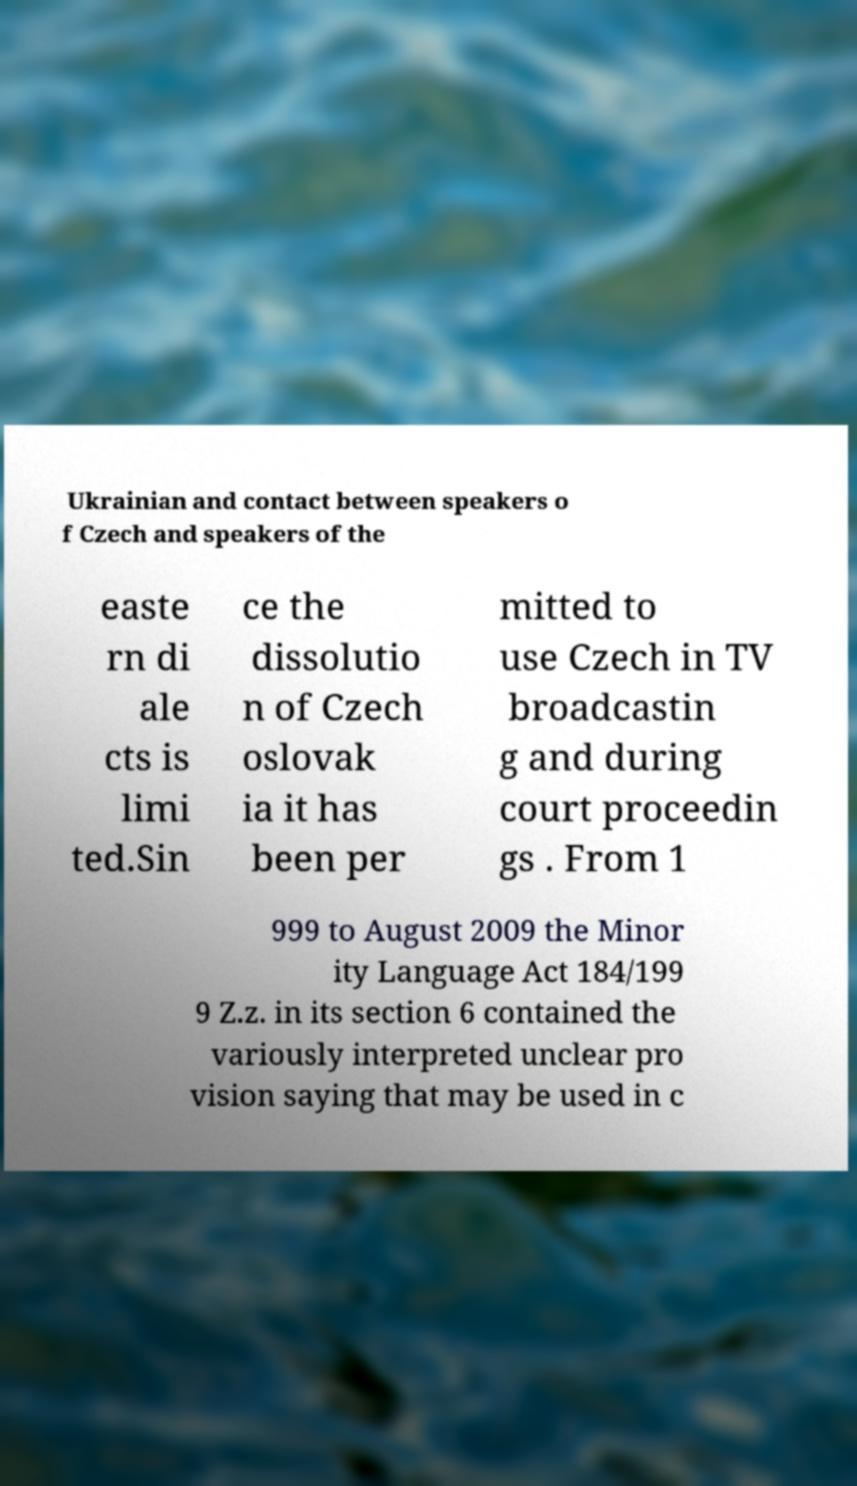Can you read and provide the text displayed in the image?This photo seems to have some interesting text. Can you extract and type it out for me? Ukrainian and contact between speakers o f Czech and speakers of the easte rn di ale cts is limi ted.Sin ce the dissolutio n of Czech oslovak ia it has been per mitted to use Czech in TV broadcastin g and during court proceedin gs . From 1 999 to August 2009 the Minor ity Language Act 184/199 9 Z.z. in its section 6 contained the variously interpreted unclear pro vision saying that may be used in c 